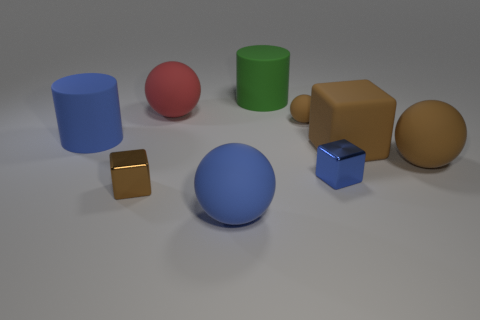There is a small matte thing that is the same shape as the big red rubber thing; what color is it?
Provide a short and direct response. Brown. There is a tiny sphere that is made of the same material as the large red sphere; what color is it?
Offer a very short reply. Brown. How many blue rubber objects have the same size as the brown shiny block?
Your answer should be compact. 0. What material is the small brown block?
Provide a short and direct response. Metal. Are there more big rubber things than tiny yellow metallic balls?
Keep it short and to the point. Yes. Do the big red thing and the large green matte object have the same shape?
Ensure brevity in your answer.  No. Is there any other thing that has the same shape as the red matte thing?
Offer a very short reply. Yes. Do the large cylinder that is left of the big green rubber cylinder and the tiny object that is behind the big brown rubber block have the same color?
Offer a very short reply. No. Is the number of big cylinders that are in front of the matte block less than the number of big things that are right of the green cylinder?
Your answer should be compact. Yes. The big matte object that is on the left side of the brown metallic thing has what shape?
Offer a very short reply. Cylinder. 